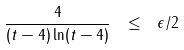<formula> <loc_0><loc_0><loc_500><loc_500>\frac { 4 } { ( t - 4 ) \ln ( t - 4 ) } \ \leq \ \epsilon / 2</formula> 